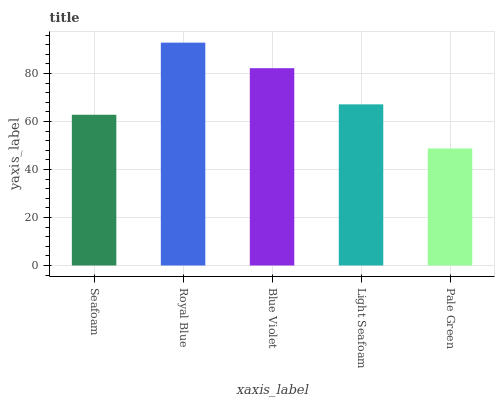Is Pale Green the minimum?
Answer yes or no. Yes. Is Royal Blue the maximum?
Answer yes or no. Yes. Is Blue Violet the minimum?
Answer yes or no. No. Is Blue Violet the maximum?
Answer yes or no. No. Is Royal Blue greater than Blue Violet?
Answer yes or no. Yes. Is Blue Violet less than Royal Blue?
Answer yes or no. Yes. Is Blue Violet greater than Royal Blue?
Answer yes or no. No. Is Royal Blue less than Blue Violet?
Answer yes or no. No. Is Light Seafoam the high median?
Answer yes or no. Yes. Is Light Seafoam the low median?
Answer yes or no. Yes. Is Blue Violet the high median?
Answer yes or no. No. Is Royal Blue the low median?
Answer yes or no. No. 